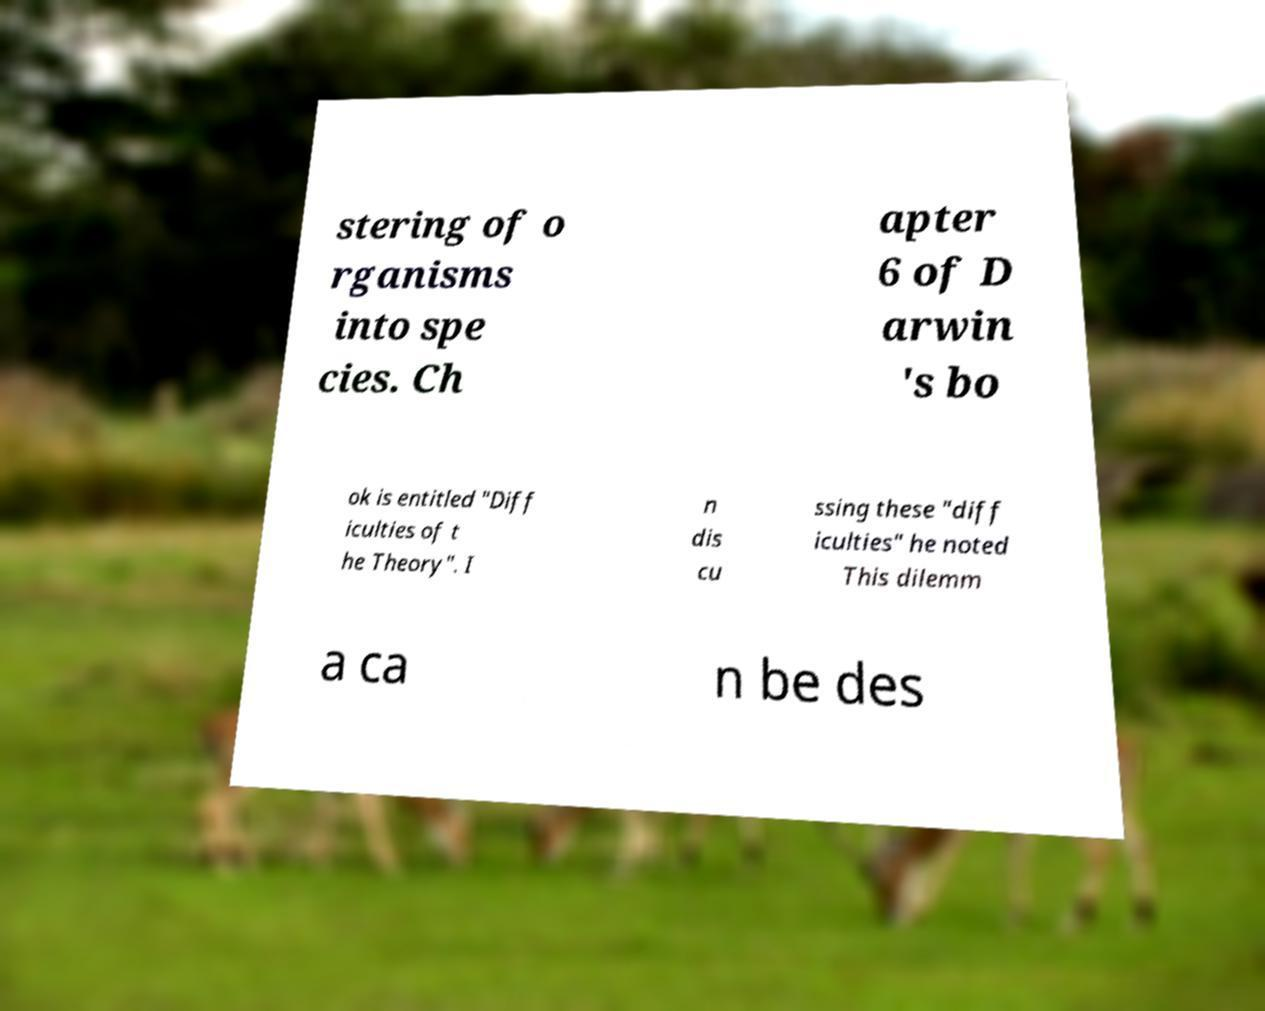What messages or text are displayed in this image? I need them in a readable, typed format. stering of o rganisms into spe cies. Ch apter 6 of D arwin 's bo ok is entitled "Diff iculties of t he Theory". I n dis cu ssing these "diff iculties" he noted This dilemm a ca n be des 